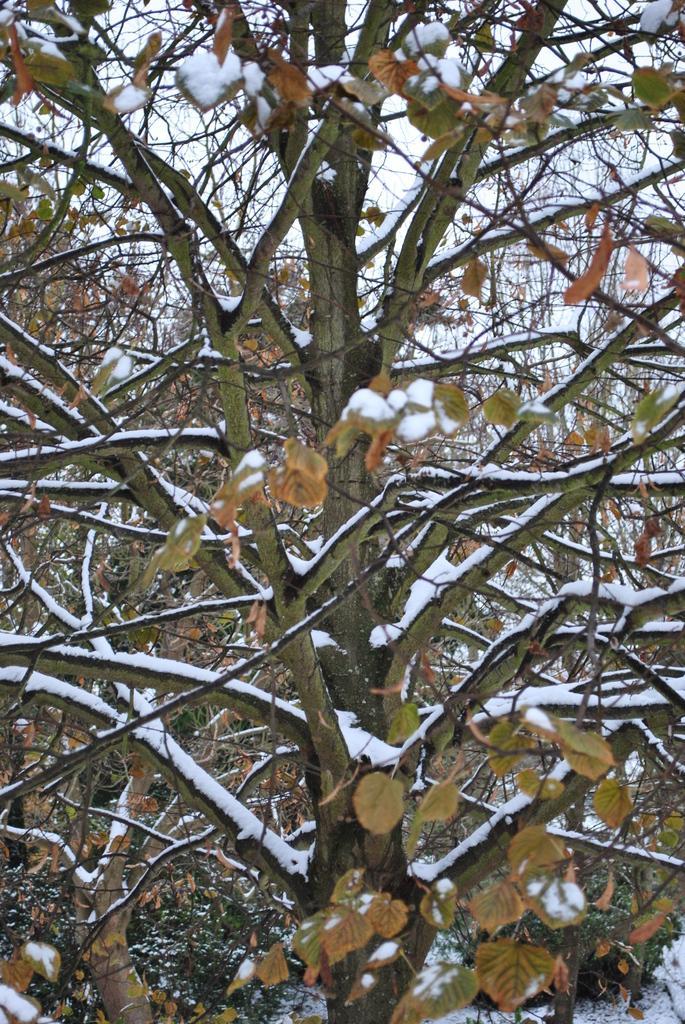In one or two sentences, can you explain what this image depicts? In this image there is a tree with snow on it. 